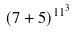Convert formula to latex. <formula><loc_0><loc_0><loc_500><loc_500>( 7 + 5 ) ^ { 1 1 ^ { 3 } }</formula> 